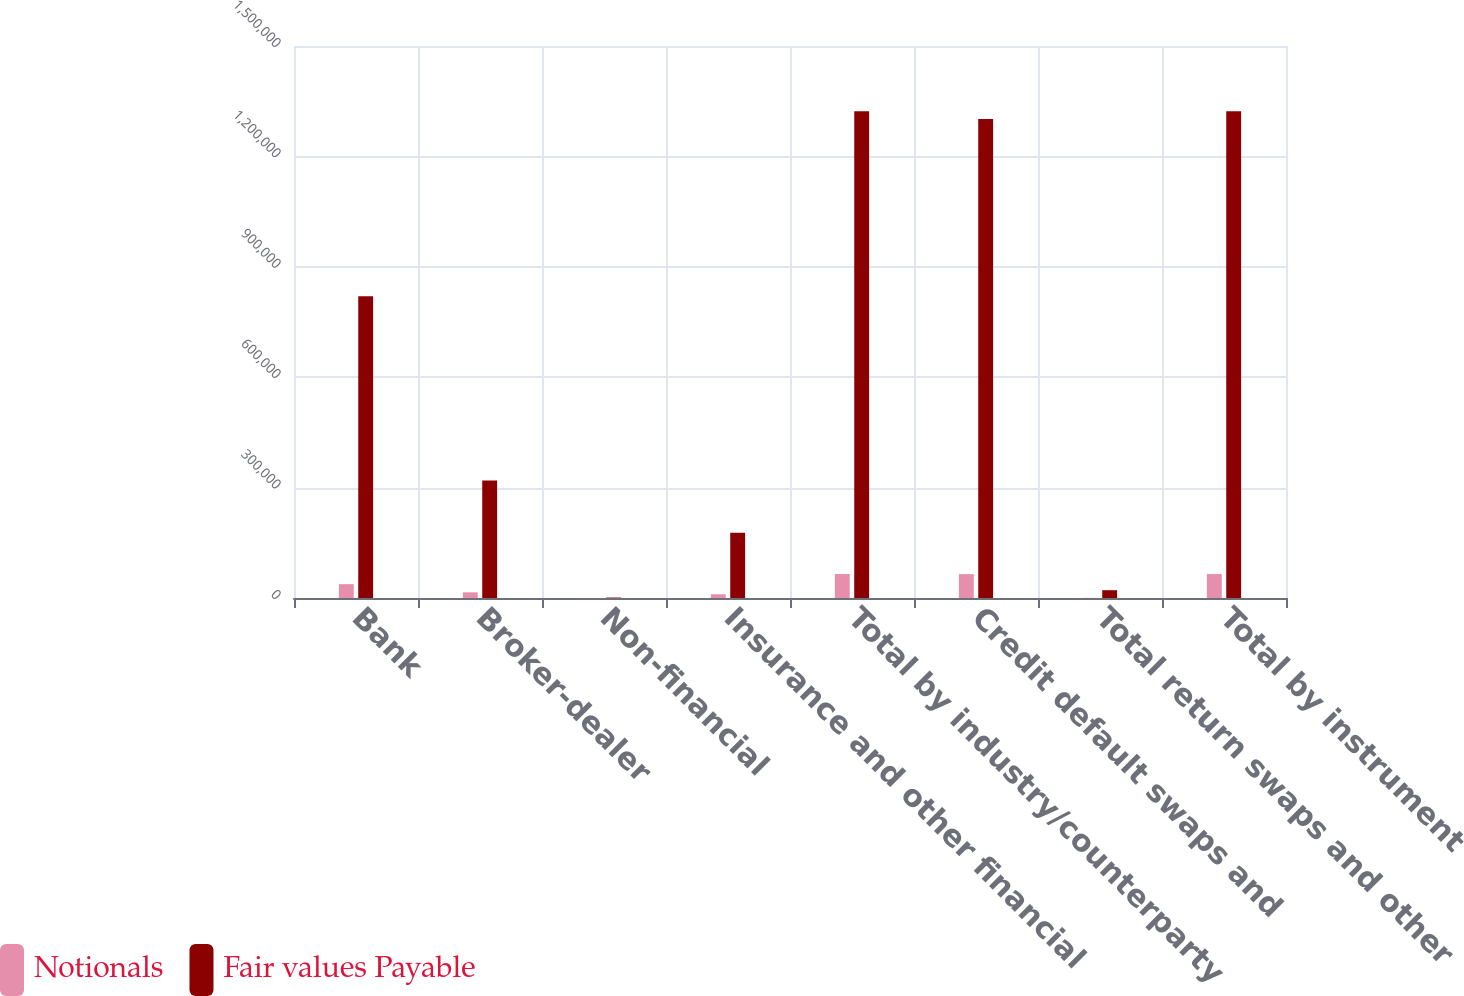Convert chart. <chart><loc_0><loc_0><loc_500><loc_500><stacked_bar_chart><ecel><fcel>Bank<fcel>Broker-dealer<fcel>Non-financial<fcel>Insurance and other financial<fcel>Total by industry/counterparty<fcel>Credit default swaps and<fcel>Total return swaps and other<fcel>Total by instrument<nl><fcel>Notionals<fcel>37586<fcel>15428<fcel>93<fcel>10108<fcel>65129<fcel>64840<fcel>289<fcel>65129<nl><fcel>Fair values Payable<fcel>820211<fcel>319625<fcel>1277<fcel>177171<fcel>1.32269e+06<fcel>1.30151e+06<fcel>21179<fcel>1.32269e+06<nl></chart> 